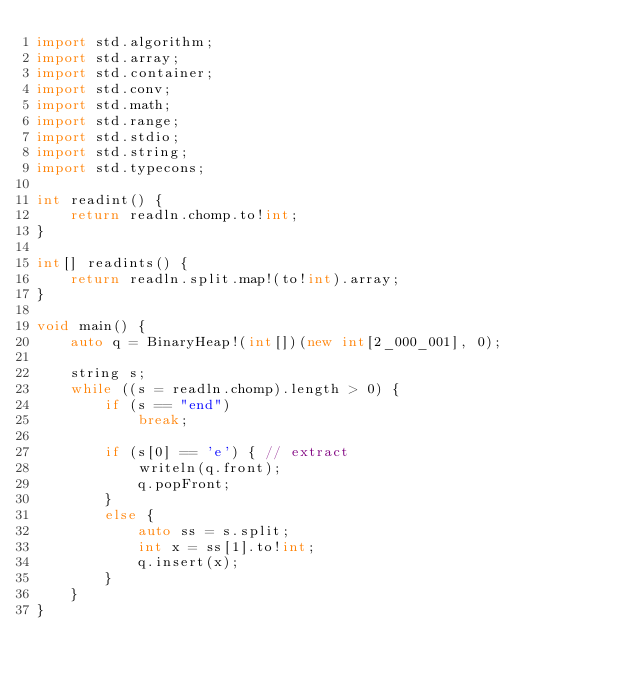<code> <loc_0><loc_0><loc_500><loc_500><_D_>import std.algorithm;
import std.array;
import std.container;
import std.conv;
import std.math;
import std.range;
import std.stdio;
import std.string;
import std.typecons;

int readint() {
    return readln.chomp.to!int;
}

int[] readints() {
    return readln.split.map!(to!int).array;
}

void main() {
    auto q = BinaryHeap!(int[])(new int[2_000_001], 0);

    string s;
    while ((s = readln.chomp).length > 0) {
        if (s == "end")
            break;

        if (s[0] == 'e') { // extract
            writeln(q.front);
            q.popFront;
        }
        else {
            auto ss = s.split;
            int x = ss[1].to!int;
            q.insert(x);
        }
    }
}

</code> 